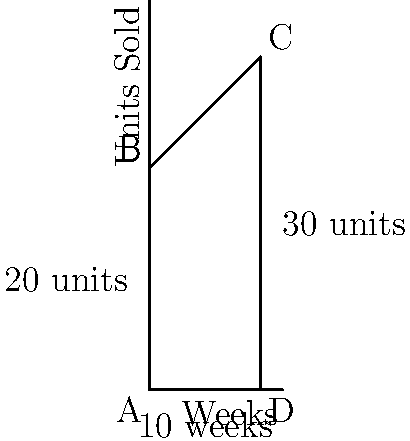As a data analyst, you're tasked with modeling sales trends for a new product over its first 10 weeks. The sales data can be approximated by a trapezoid, as shown in the figure. If the initial weekly sales were 20 units, increasing to 30 units by week 10, what was the total number of units sold over this period? To solve this problem, we need to calculate the area of the trapezoid, which represents the total units sold over the 10-week period. Let's approach this step-by-step:

1) The formula for the area of a trapezoid is:
   $$A = \frac{1}{2}(b_1 + b_2)h$$
   where $A$ is the area, $b_1$ and $b_2$ are the parallel sides, and $h$ is the height.

2) From the figure, we can identify:
   - $b_1 = 20$ units (initial weekly sales)
   - $b_2 = 30$ units (final weekly sales)
   - $h = 10$ weeks

3) Plugging these values into the formula:
   $$A = \frac{1}{2}(20 + 30) \times 10$$

4) Simplify:
   $$A = \frac{1}{2}(50) \times 10 = 25 \times 10 = 250$$

5) Therefore, the total number of units sold over the 10-week period is 250 units.

This method of using a trapezoid to model sales trends allows for a simple yet effective way to estimate total sales when there's a linear increase over time.
Answer: 250 units 